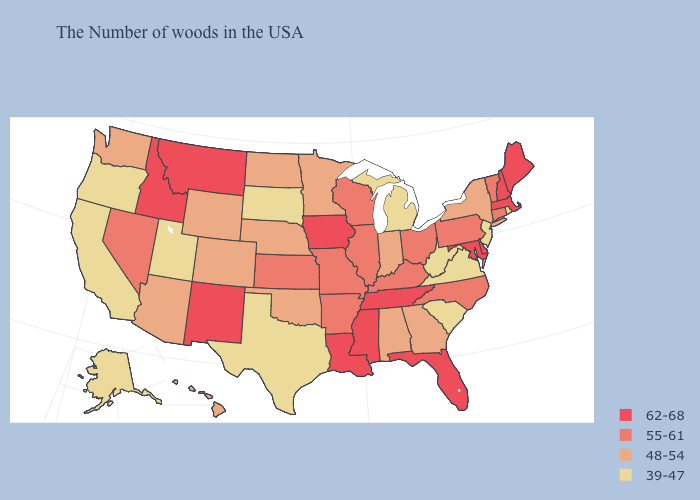What is the highest value in states that border Florida?
Answer briefly. 48-54. What is the value of Rhode Island?
Be succinct. 39-47. Does Utah have the same value as Mississippi?
Quick response, please. No. What is the highest value in states that border Wisconsin?
Give a very brief answer. 62-68. What is the value of Michigan?
Concise answer only. 39-47. What is the value of Iowa?
Be succinct. 62-68. How many symbols are there in the legend?
Quick response, please. 4. Is the legend a continuous bar?
Quick response, please. No. What is the lowest value in states that border Texas?
Be succinct. 48-54. Name the states that have a value in the range 55-61?
Answer briefly. Vermont, Connecticut, Pennsylvania, North Carolina, Ohio, Kentucky, Wisconsin, Illinois, Missouri, Arkansas, Kansas, Nevada. What is the value of Florida?
Answer briefly. 62-68. Name the states that have a value in the range 62-68?
Short answer required. Maine, Massachusetts, New Hampshire, Delaware, Maryland, Florida, Tennessee, Mississippi, Louisiana, Iowa, New Mexico, Montana, Idaho. Does Maine have the highest value in the Northeast?
Short answer required. Yes. What is the value of Wisconsin?
Short answer required. 55-61. What is the value of Minnesota?
Write a very short answer. 48-54. 